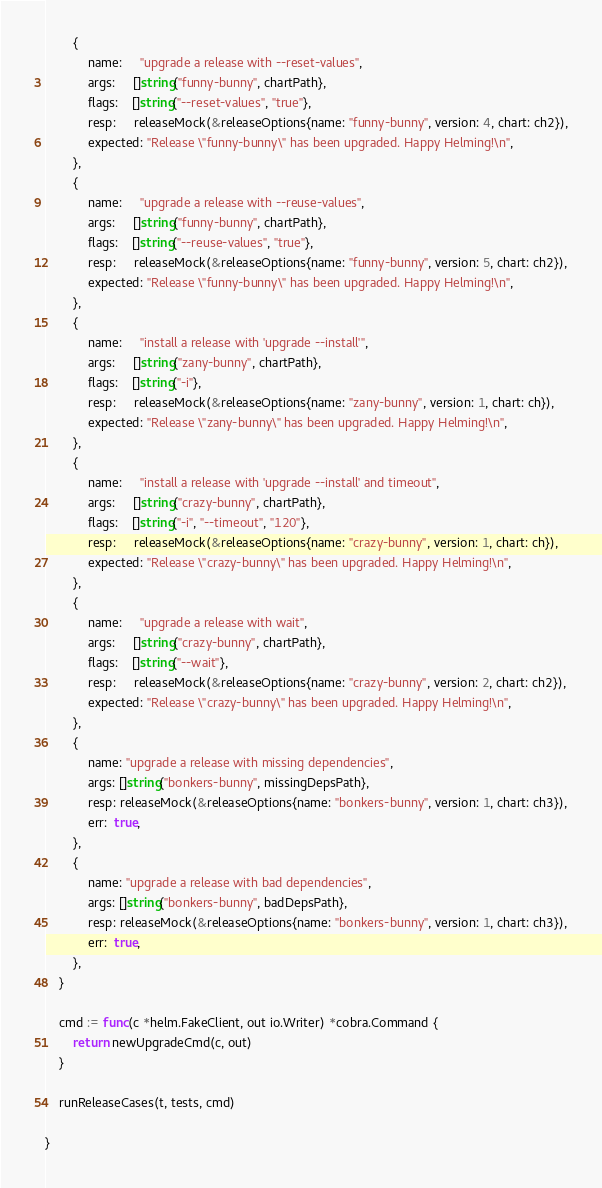Convert code to text. <code><loc_0><loc_0><loc_500><loc_500><_Go_>		{
			name:     "upgrade a release with --reset-values",
			args:     []string{"funny-bunny", chartPath},
			flags:    []string{"--reset-values", "true"},
			resp:     releaseMock(&releaseOptions{name: "funny-bunny", version: 4, chart: ch2}),
			expected: "Release \"funny-bunny\" has been upgraded. Happy Helming!\n",
		},
		{
			name:     "upgrade a release with --reuse-values",
			args:     []string{"funny-bunny", chartPath},
			flags:    []string{"--reuse-values", "true"},
			resp:     releaseMock(&releaseOptions{name: "funny-bunny", version: 5, chart: ch2}),
			expected: "Release \"funny-bunny\" has been upgraded. Happy Helming!\n",
		},
		{
			name:     "install a release with 'upgrade --install'",
			args:     []string{"zany-bunny", chartPath},
			flags:    []string{"-i"},
			resp:     releaseMock(&releaseOptions{name: "zany-bunny", version: 1, chart: ch}),
			expected: "Release \"zany-bunny\" has been upgraded. Happy Helming!\n",
		},
		{
			name:     "install a release with 'upgrade --install' and timeout",
			args:     []string{"crazy-bunny", chartPath},
			flags:    []string{"-i", "--timeout", "120"},
			resp:     releaseMock(&releaseOptions{name: "crazy-bunny", version: 1, chart: ch}),
			expected: "Release \"crazy-bunny\" has been upgraded. Happy Helming!\n",
		},
		{
			name:     "upgrade a release with wait",
			args:     []string{"crazy-bunny", chartPath},
			flags:    []string{"--wait"},
			resp:     releaseMock(&releaseOptions{name: "crazy-bunny", version: 2, chart: ch2}),
			expected: "Release \"crazy-bunny\" has been upgraded. Happy Helming!\n",
		},
		{
			name: "upgrade a release with missing dependencies",
			args: []string{"bonkers-bunny", missingDepsPath},
			resp: releaseMock(&releaseOptions{name: "bonkers-bunny", version: 1, chart: ch3}),
			err:  true,
		},
		{
			name: "upgrade a release with bad dependencies",
			args: []string{"bonkers-bunny", badDepsPath},
			resp: releaseMock(&releaseOptions{name: "bonkers-bunny", version: 1, chart: ch3}),
			err:  true,
		},
	}

	cmd := func(c *helm.FakeClient, out io.Writer) *cobra.Command {
		return newUpgradeCmd(c, out)
	}

	runReleaseCases(t, tests, cmd)

}
</code> 